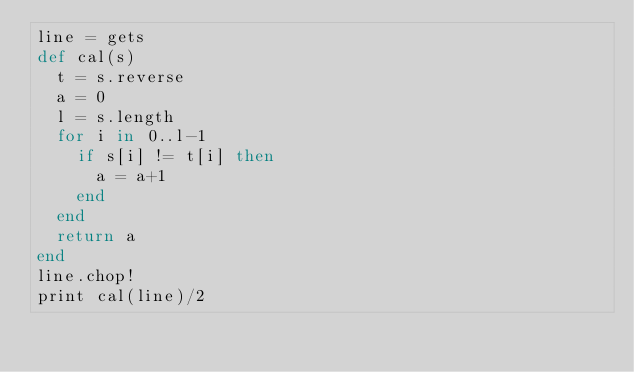Convert code to text. <code><loc_0><loc_0><loc_500><loc_500><_Ruby_>line = gets
def cal(s)
  t = s.reverse
  a = 0
  l = s.length
  for i in 0..l-1
    if s[i] != t[i] then
      a = a+1
    end
  end
  return a
end
line.chop!  
print cal(line)/2</code> 